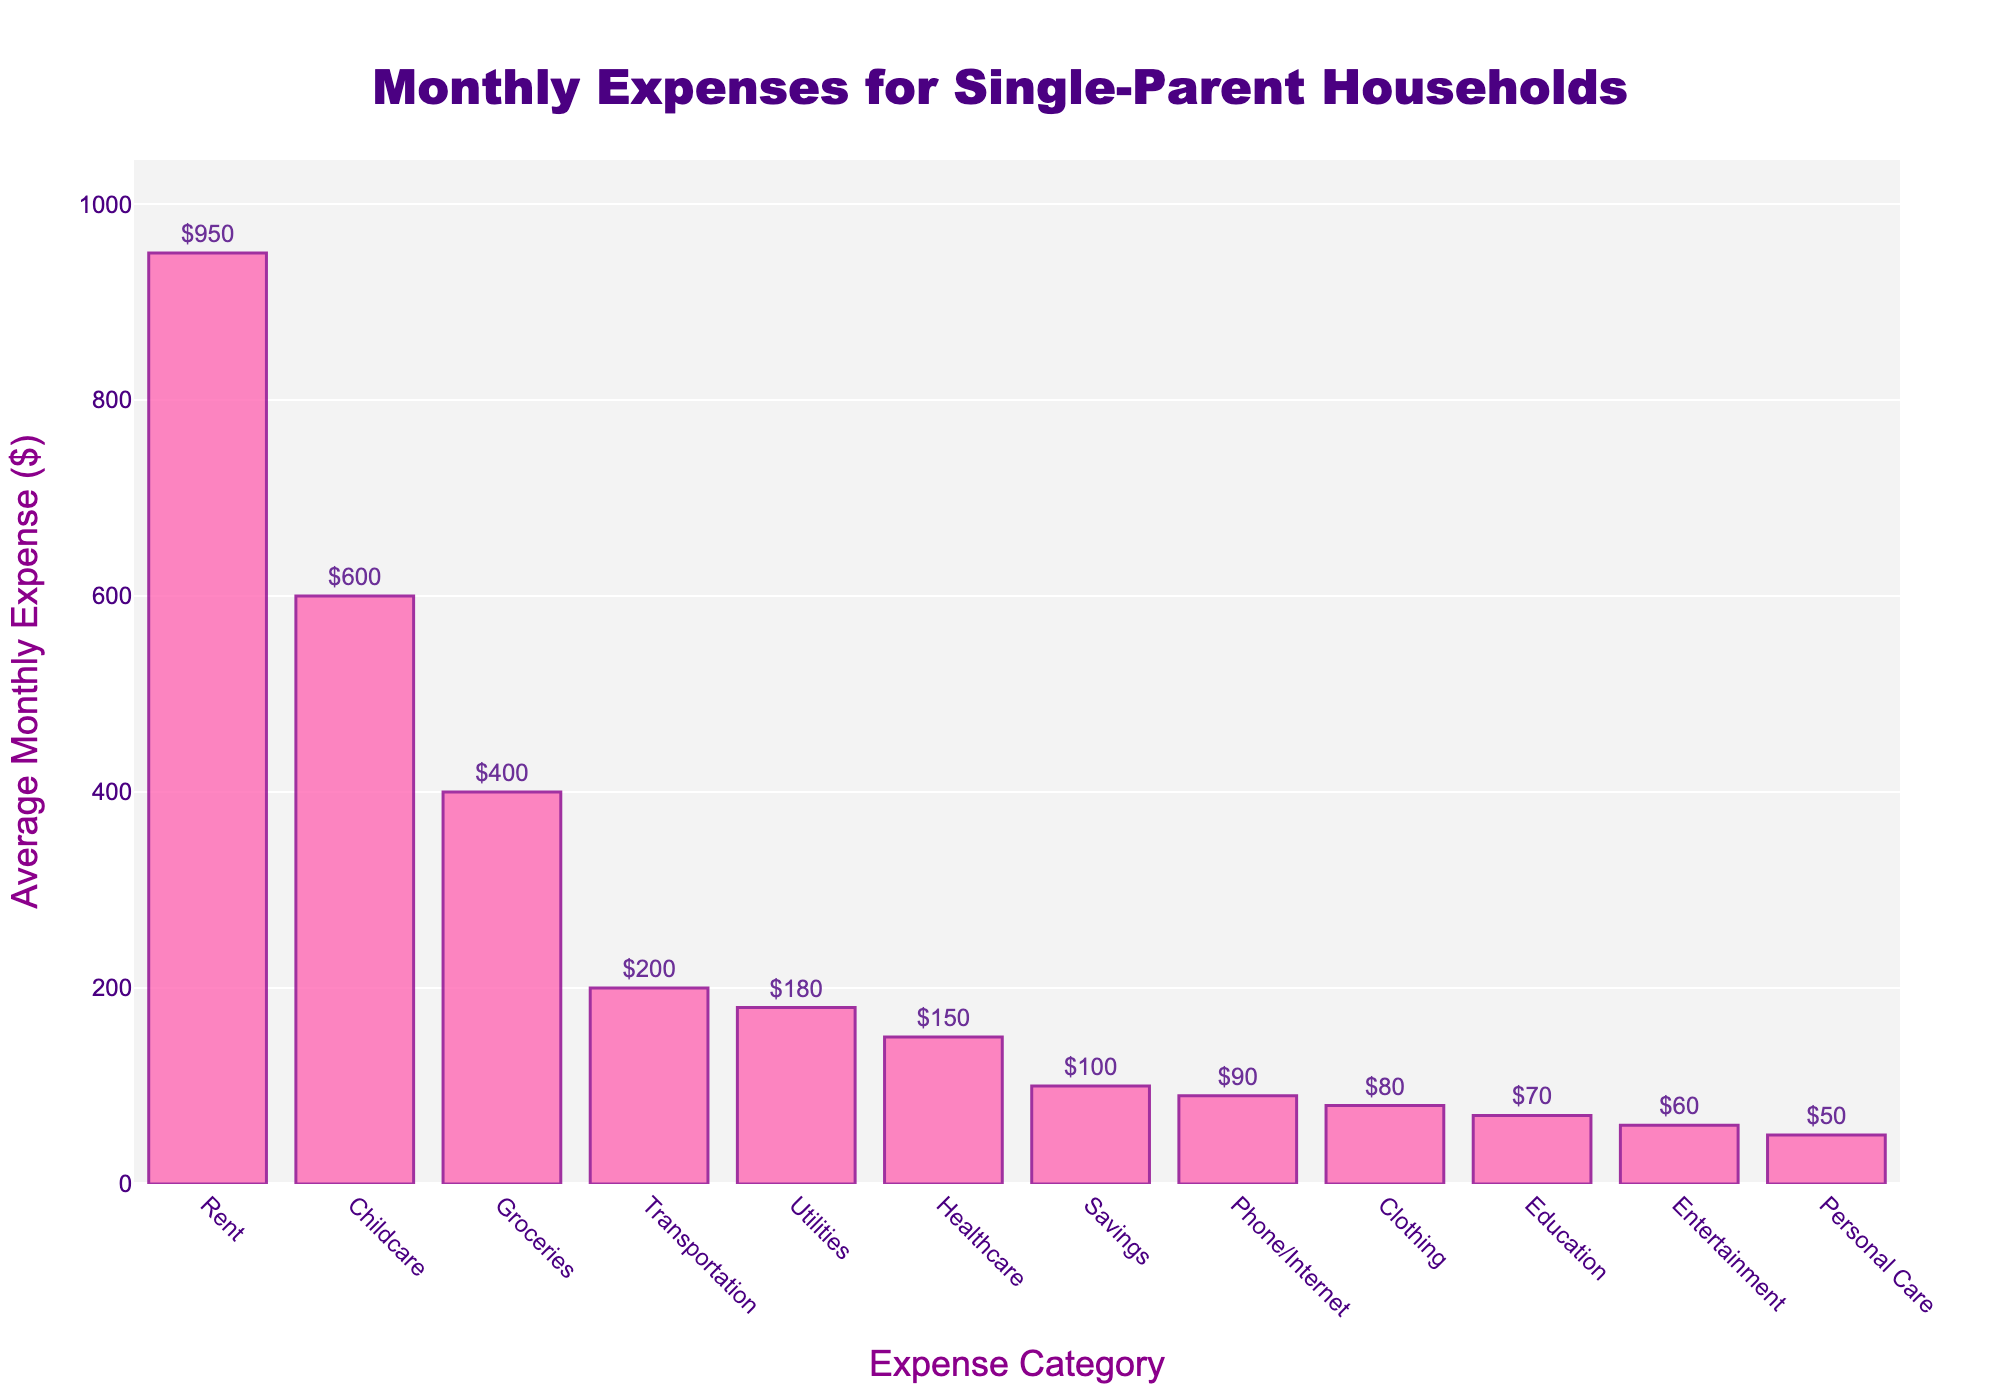What's the category with the highest average monthly expense? The tallest bar in the chart represents Rent with an average monthly expense of $950, making it the highest expense category.
Answer: Rent Which expense category is the second highest after Rent? The second tallest bar in the chart represents Childcare with an average monthly expense of $600, making it the second highest expense category.
Answer: Childcare What's the total average monthly expense for Groceries, Transportation, and Healthcare together? Sum the average monthly expenses for Groceries ($400), Transportation ($200), and Healthcare ($150). The total is $400 + $200 + $150 = $750.
Answer: $750 Is the average monthly expense for Childcare greater or less than the expense for Savings and Education combined? The average monthly expense for Childcare is $600. Combine Savings ($100) and Education ($70), which equals $170. Since $600 is greater than $170, the expense for Childcare is greater.
Answer: Greater What is the difference between the highest and lowest average monthly expenses? The highest average monthly expense is for Rent ($950) and the lowest is for Personal Care ($50). The difference is $950 - $50 = $900.
Answer: $900 How does the expense for Utilities compare to the expense for Phone/Internet? The bar for Utilities represents an average monthly expense of $180, while the bar for Phone/Internet represents $90. Therefore, Utilities is higher than Phone/Internet.
Answer: Higher What's the combined average monthly expense for Utilities, Healthcare, and Entertainment? Sum the average monthly expenses for Utilities ($180), Healthcare ($150), and Entertainment ($60). The total is $180 + $150 + $60 = $390.
Answer: $390 Which categories have average monthly expenses less than $100? The categories with expenses lower than $100 are Clothing ($80), Personal Care ($50), Education ($70), Entertainment ($60), and Phone/Internet ($90).
Answer: Clothing, Personal Care, Education, Entertainment, Phone/Internet Is the average monthly expense for Transportation higher than that for Groceries? The bar for Transportation shows $200, while the bar for Groceries shows $400. Therefore, the expense for Transportation is not higher than that for Groceries.
Answer: No 